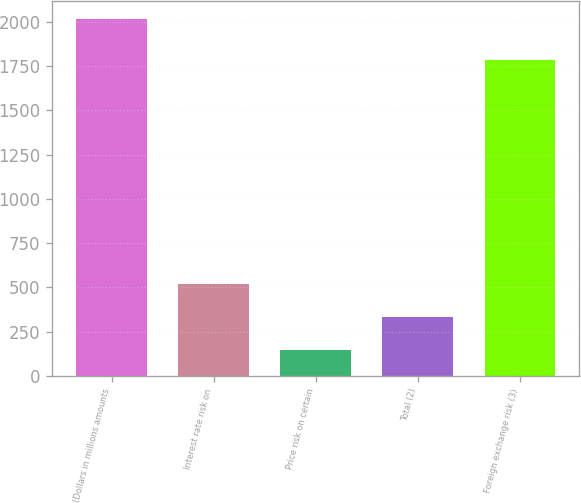Convert chart. <chart><loc_0><loc_0><loc_500><loc_500><bar_chart><fcel>(Dollars in millions amounts<fcel>Interest rate risk on<fcel>Price risk on certain<fcel>Total (2)<fcel>Foreign exchange risk (3)<nl><fcel>2017<fcel>521.8<fcel>148<fcel>334.9<fcel>1782<nl></chart> 